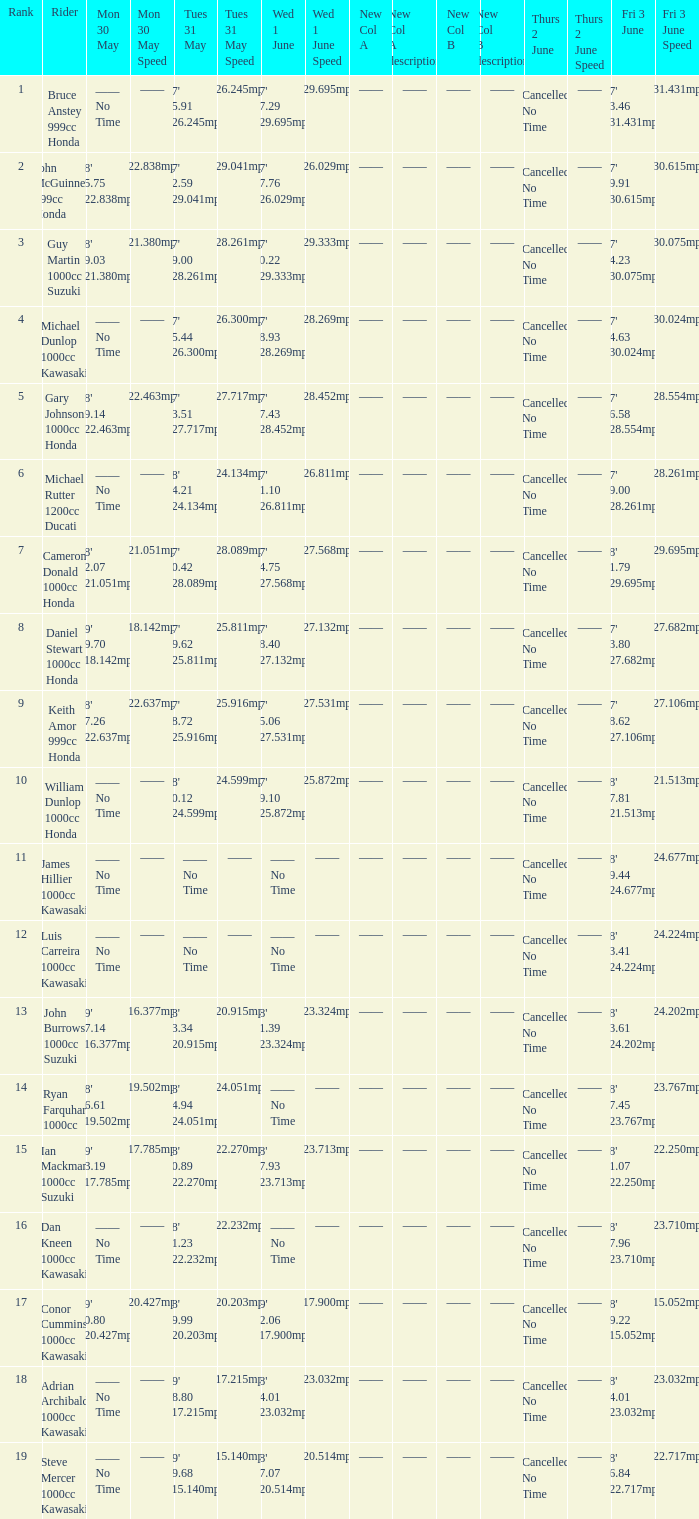What is the Thurs 2 June time for the rider with a Fri 3 June time of 17' 36.58 128.554mph? Cancelled No Time. Give me the full table as a dictionary. {'header': ['Rank', 'Rider', 'Mon 30 May', 'Mon 30 May Speed', 'Tues 31 May', 'Tues 31 May Speed', 'Wed 1 June', 'Wed 1 June Speed', 'New Col A', 'New Col A description', 'New Col B', 'New Col B description', 'Thurs 2 June', 'Thurs 2 June Speed', 'Fri 3 June', 'Fri 3 June Speed '], 'rows': [['1', 'Bruce Anstey 999cc Honda', '—— No Time', '——', "17' 55.91 126.245mph", '126.245mph', "17' 27.29 129.695mph", '129.695mph', '——', '——', '——', '——', 'Cancelled No Time', '——', "17' 13.46 131.431mph", '131.431mph'], ['2', 'John McGuinness 999cc Honda', "18' 25.75 122.838mph", '122.838mph', "17' 32.59 129.041mph", '129.041mph', "17' 57.76 126.029mph", '126.029mph', '——', '——', '——', '——', 'Cancelled No Time', '——', "17' 19.91 130.615mph", '130.615mph'], ['3', 'Guy Martin 1000cc Suzuki', "18' 39.03 121.380mph", '121.380mph', "17' 39.00 128.261mph", '128.261mph', "17' 30.22 129.333mph", '129.333mph', '——', '——', '——', '——', 'Cancelled No Time', '——', "17' 24.23 130.075mph", '130.075mph'], ['4', 'Michael Dunlop 1000cc Kawasaki', '—— No Time', '——', "17' 55.44 126.300mph", '126.300mph', "17' 38.93 128.269mph", '128.269mph', '——', '——', '——', '——', 'Cancelled No Time', '——', "17' 24.63 130.024mph", '130.024mph'], ['5', 'Gary Johnson 1000cc Honda', "18' 29.14 122.463mph", '122.463mph', "17' 43.51 127.717mph", '127.717mph', "17' 37.43 128.452mph", '128.452mph', '——', '——', '——', '——', 'Cancelled No Time', '——', "17' 36.58 128.554mph", '128.554mph'], ['6', 'Michael Rutter 1200cc Ducati', '—— No Time', '——', "18' 14.21 124.134mph", '124.134mph', "17' 51.10 126.811mph", '126.811mph', '——', '——', '——', '——', 'Cancelled No Time', '——', "17' 39.00 128.261mph", '128.261mph'], ['7', 'Cameron Donald 1000cc Honda', "18' 42.07 121.051mph", '121.051mph', "17' 40.42 128.089mph", '128.089mph', "17' 44.75 127.568mph", '127.568mph', '——', '——', '——', '——', 'Cancelled No Time', '——', "18' 01.79 129.695mph", '129.695mph'], ['8', 'Daniel Stewart 1000cc Honda', "19' 09.70 118.142mph", '118.142mph', "17' 59.62 125.811mph", '125.811mph', "17' 48.40 127.132mph", '127.132mph', '——', '——', '——', '——', 'Cancelled No Time', '——', "17' 43.80 127.682mph", '127.682mph'], ['9', 'Keith Amor 999cc Honda', "18' 27.26 122.637mph", '122.637mph', "17' 58.72 125.916mph", '125.916mph', "17' 45.06 127.531mph", '127.531mph', '——', '——', '——', '——', 'Cancelled No Time', '——', "17' 48.62 127.106mph", '127.106mph'], ['10', 'William Dunlop 1000cc Honda', '—— No Time', '——', "18' 10.12 124.599mph", '124.599mph', "17' 59.10 125.872mph", '125.872mph', '——', '——', '——', '——', 'Cancelled No Time', '——', "18' 37.81 121.513mph", '121.513mph'], ['11', 'James Hillier 1000cc Kawasaki', '—— No Time', '——', '—— No Time', '——', '—— No Time', '——', '——', '——', '——', '——', 'Cancelled No Time', '——', "18' 09.44 124.677mph", '124.677mph'], ['12', 'Luis Carreira 1000cc Kawasaki', '—— No Time', '——', '—— No Time', '——', '—— No Time', '——', '——', '——', '——', '——', 'Cancelled No Time', '——', "18' 13.41 124.224mph", '124.224mph'], ['13', 'John Burrows 1000cc Suzuki', "19' 27.14 116.377mph", '116.377mph', "18' 43.34 120.915mph", '120.915mph', "18' 21.39 123.324mph", '123.324mph', '——', '——', '——', '——', 'Cancelled No Time', '——', "18' 13.61 124.202mph", '124.202mph'], ['14', 'Ryan Farquhar 1000cc', "18' 56.61 119.502mph", '119.502mph', "18' 14.94 124.051mph", '124.051mph', '—— No Time', '——', '——', '——', '——', '——', 'Cancelled No Time', '——', "18' 17.45 123.767mph", '123.767mph'], ['15', 'Ian Mackman 1000cc Suzuki', "19' 13.19 117.785mph", '117.785mph', "18' 30.89 122.270mph", '122.270mph', "18' 17.93 123.713mph", '123.713mph', '——', '——', '——', '——', 'Cancelled No Time', '——', "18' 31.07 122.250mph", '122.250mph'], ['16', 'Dan Kneen 1000cc Kawasaki', '—— No Time', '——', "18' 31.23 122.232mph", '122.232mph', '—— No Time', '——', '——', '——', '——', '——', 'Cancelled No Time', '——', "18' 17.96 123.710mph", '123.710mph'], ['17', 'Conor Cummins 1000cc Kawasaki', "19' 40.80 120.427mph", '120.427mph', "18' 49.99 120.203mph", '120.203mph', "19' 12.06 117.900mph", '117.900mph', '——', '——', '——', '——', 'Cancelled No Time', '——', "18' 19.22 115.052mph", '115.052mph'], ['18', 'Adrian Archibald 1000cc Kawasaki', '—— No Time', '——', "19' 18.80 117.215mph", '117.215mph', "18' 24.01 123.032mph", '123.032mph', '——', '——', '——', '——', 'Cancelled No Time', '——', "18' 24.01 123.032mph", '123.032mph'], ['19', 'Steve Mercer 1000cc Kawasaki', '—— No Time', '——', "19' 39.68 115.140mph", '115.140mph', "18' 47.07 120.514mph", '120.514mph', '——', '——', '——', '——', 'Cancelled No Time', '——', "18' 26.84 122.717mph", '122.717mph']]} 